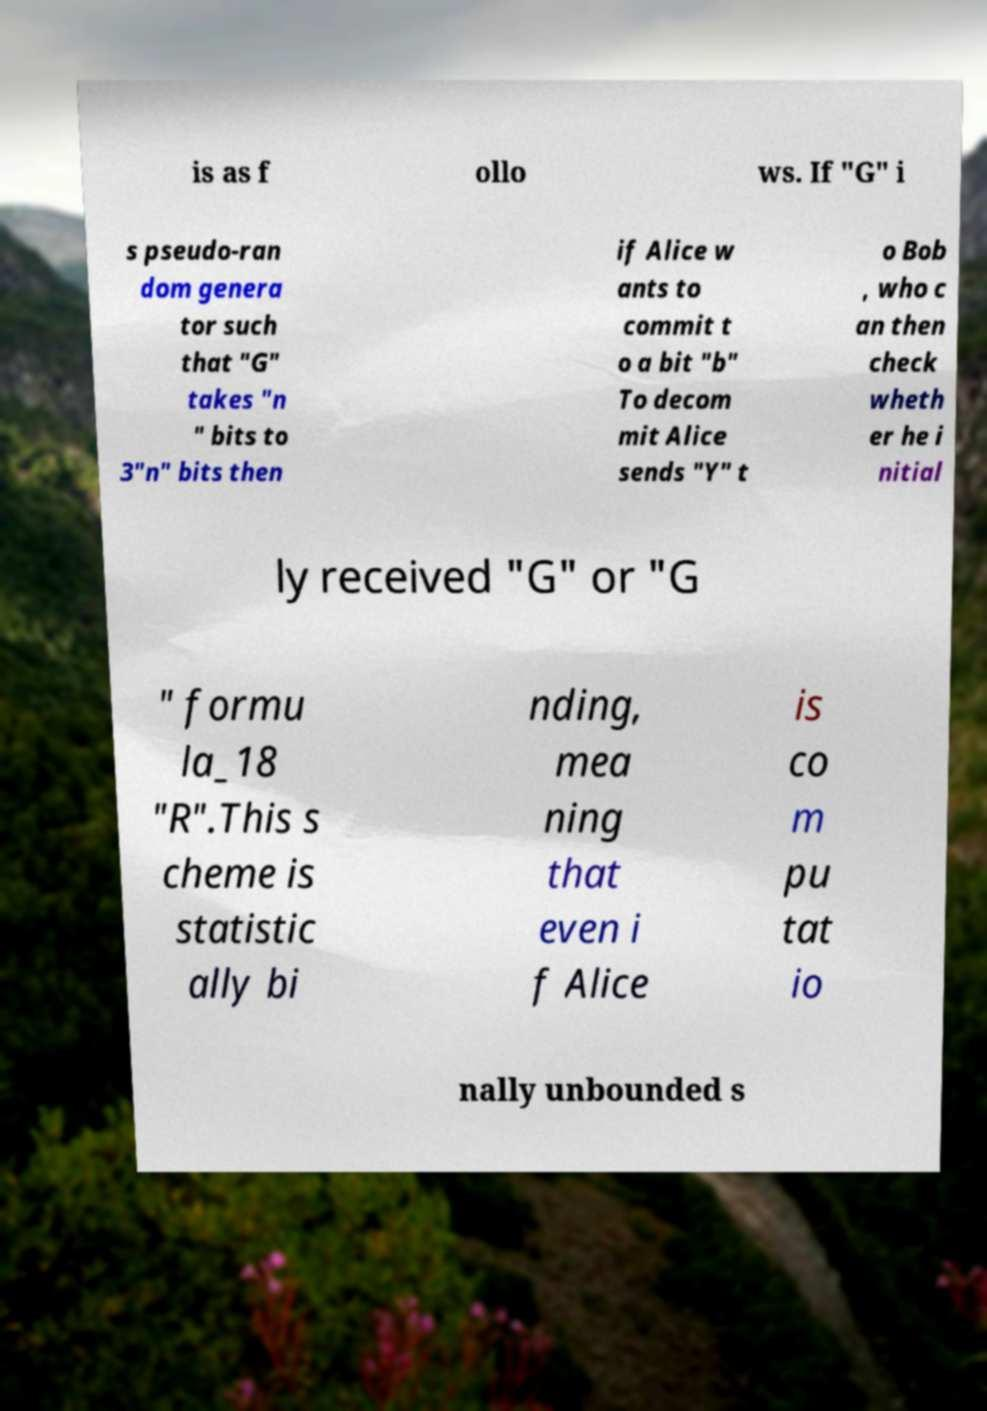For documentation purposes, I need the text within this image transcribed. Could you provide that? is as f ollo ws. If "G" i s pseudo-ran dom genera tor such that "G" takes "n " bits to 3"n" bits then if Alice w ants to commit t o a bit "b" To decom mit Alice sends "Y" t o Bob , who c an then check wheth er he i nitial ly received "G" or "G " formu la_18 "R".This s cheme is statistic ally bi nding, mea ning that even i f Alice is co m pu tat io nally unbounded s 